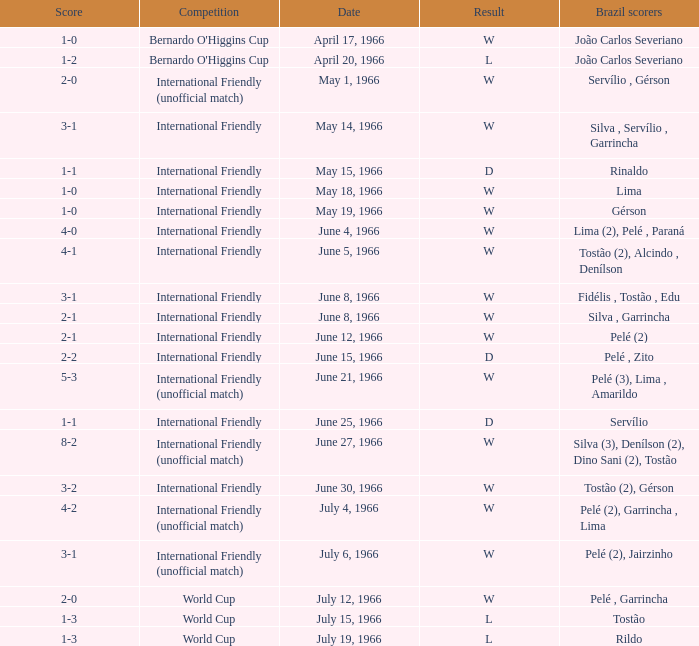What is the result when the score is 4-0? W. 